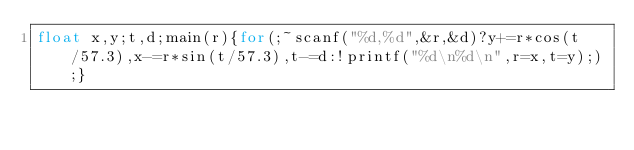Convert code to text. <code><loc_0><loc_0><loc_500><loc_500><_C_>float x,y;t,d;main(r){for(;~scanf("%d,%d",&r,&d)?y+=r*cos(t/57.3),x-=r*sin(t/57.3),t-=d:!printf("%d\n%d\n",r=x,t=y););}</code> 